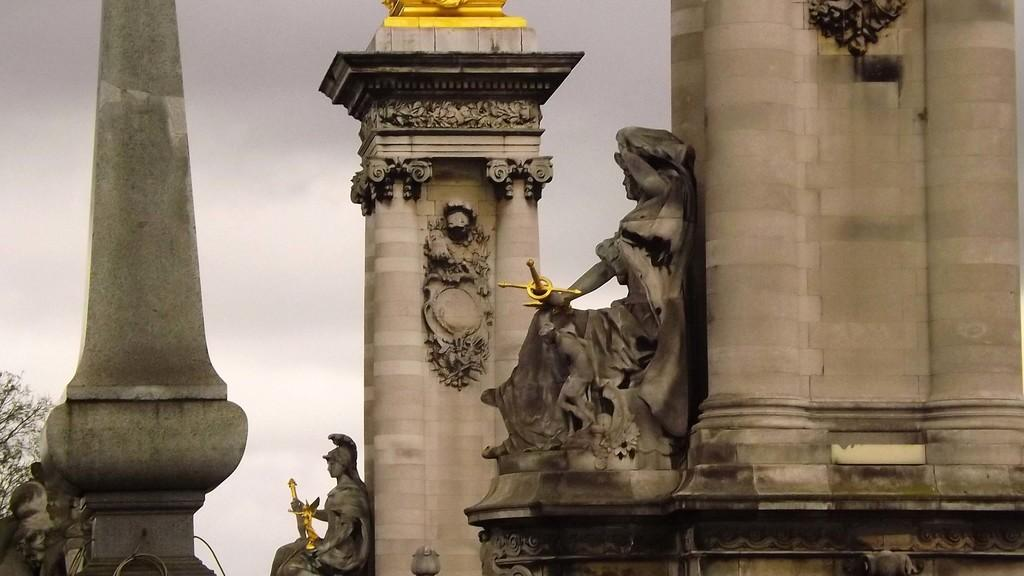What type of artwork can be seen in the image? There are sculptures in the image. What architectural elements are present in the image? There are pillars in the image. What type of vegetation is on the left side of the image? There is a tree on the left side of the image. What type of cable is hanging from the tree in the image? There is no cable present in the image; it features sculptures, pillars, and a tree. How many knees can be seen in the image? There are no knees visible in the image. 